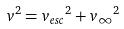Convert formula to latex. <formula><loc_0><loc_0><loc_500><loc_500>v ^ { 2 } = { v _ { e s c } } ^ { 2 } + { v _ { \infty } } ^ { 2 }</formula> 